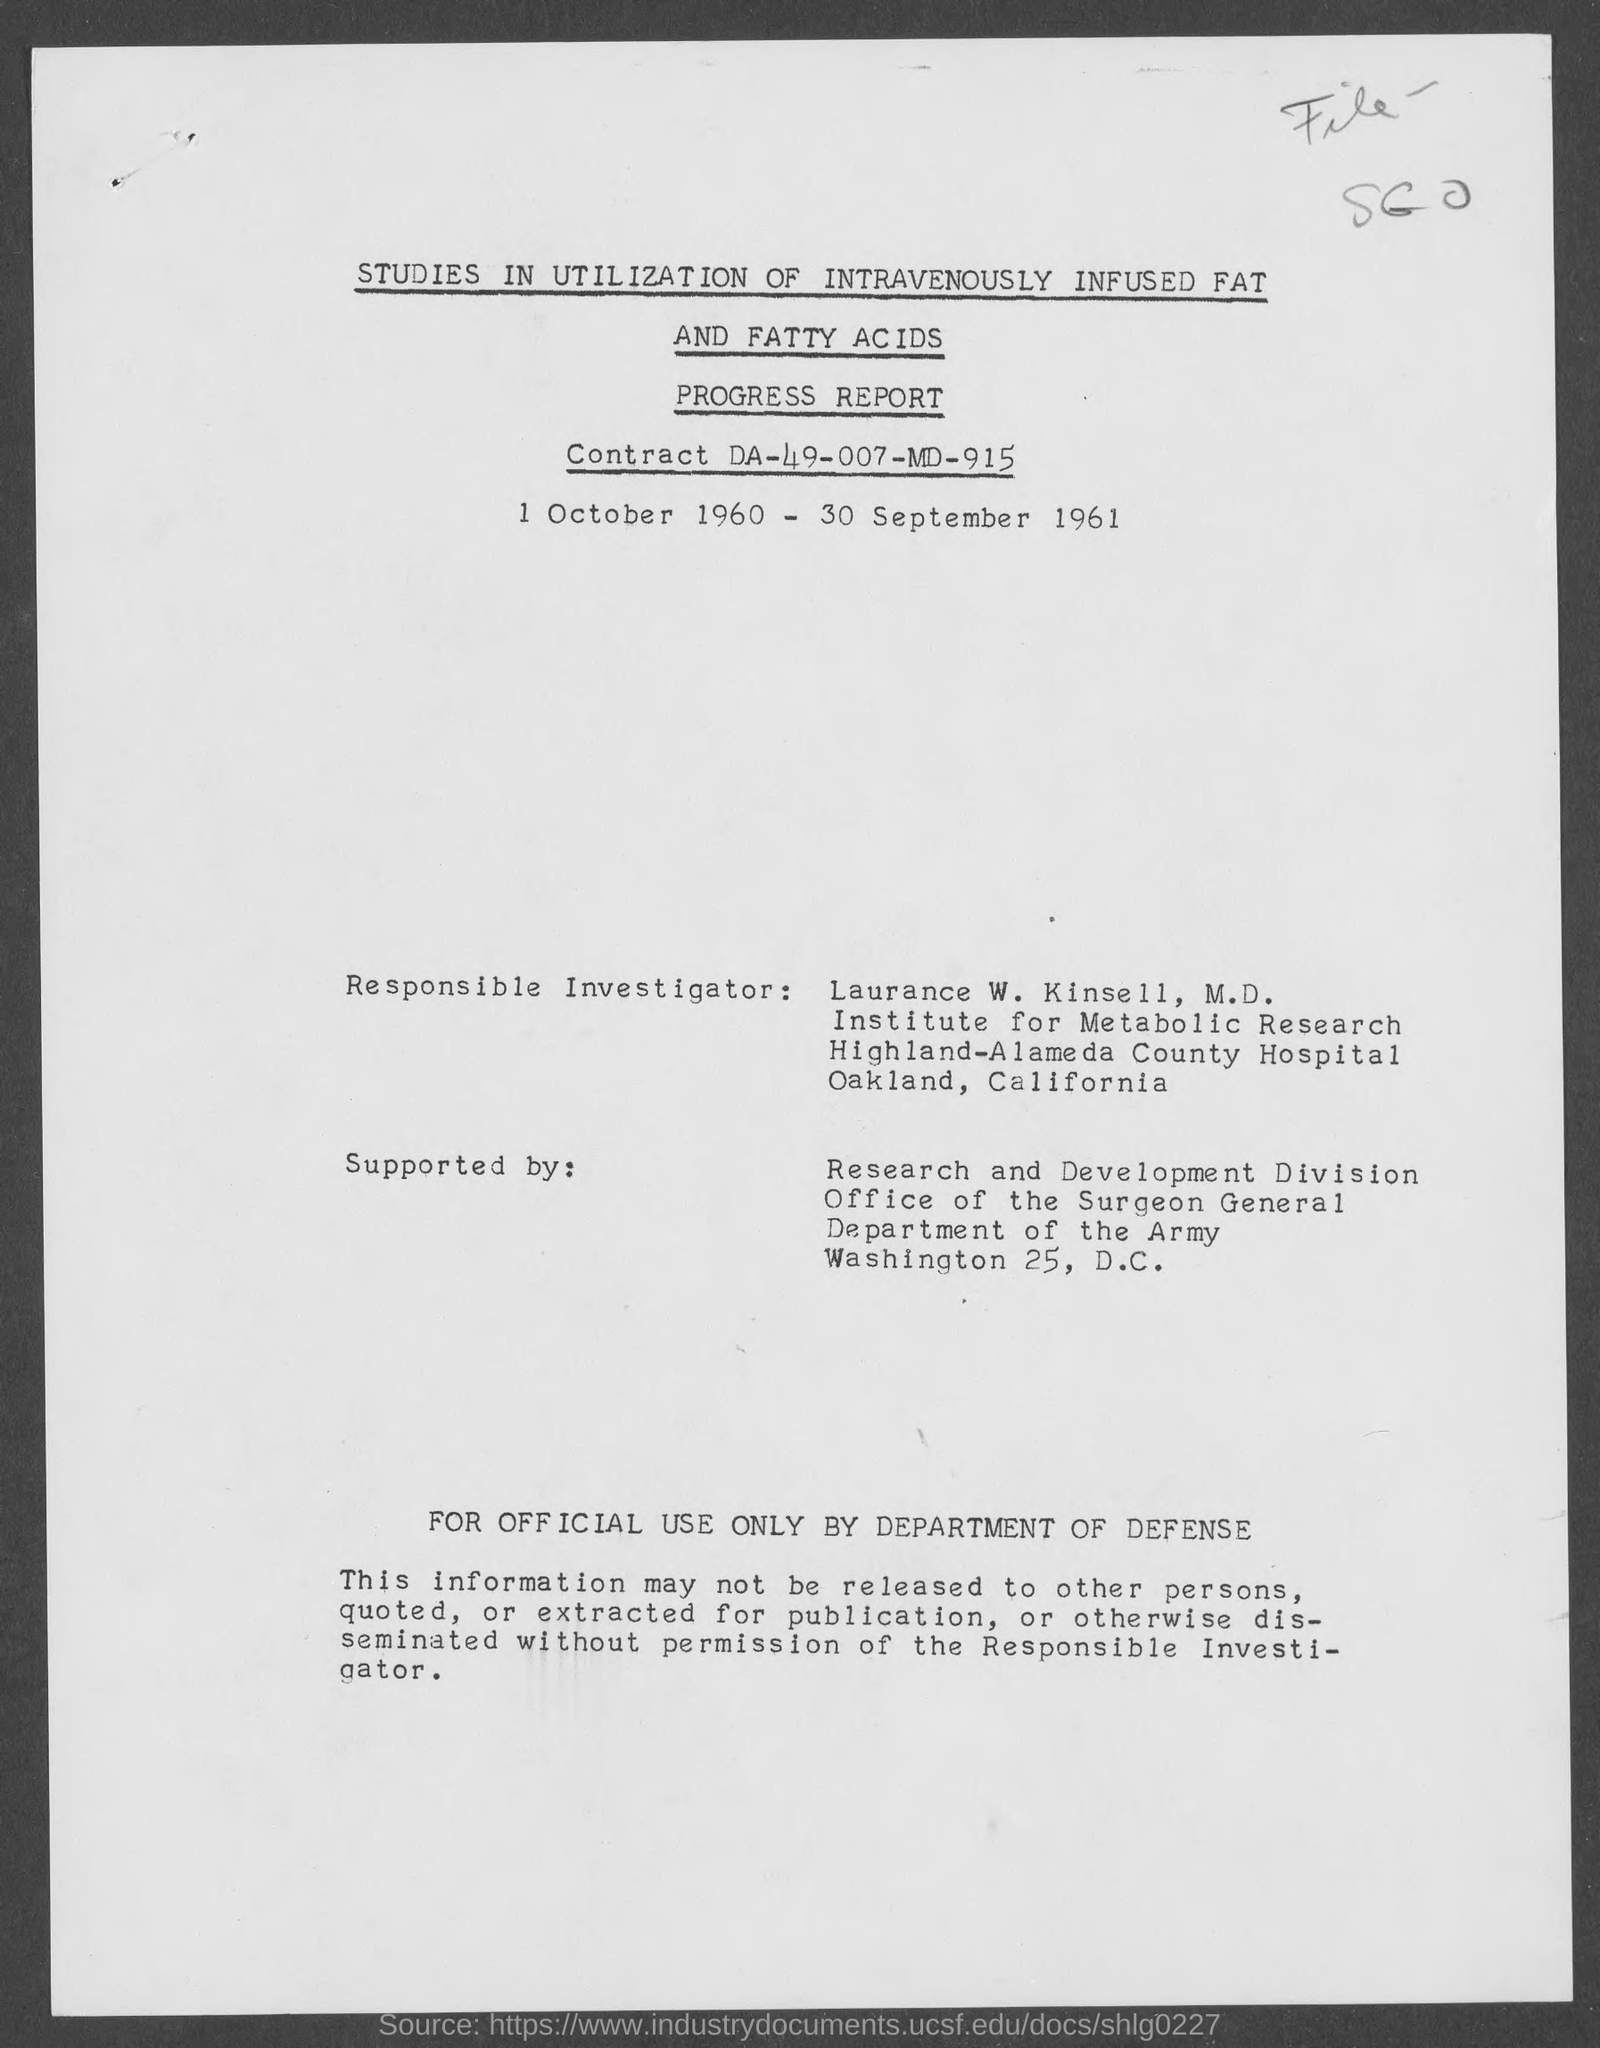Give some essential details in this illustration. The contract number is DA-49-007-MD-915. 